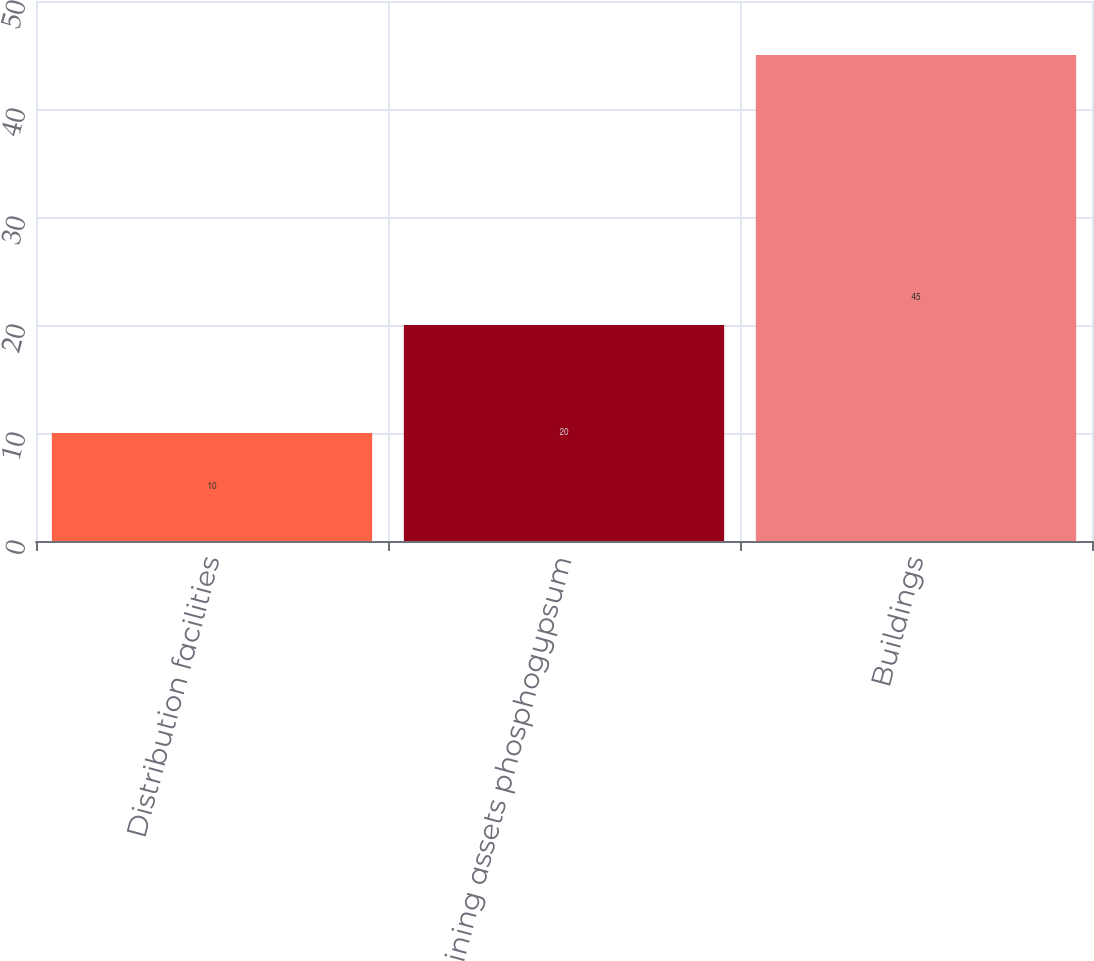Convert chart to OTSL. <chart><loc_0><loc_0><loc_500><loc_500><bar_chart><fcel>Distribution facilities<fcel>Mining assets phosphogypsum<fcel>Buildings<nl><fcel>10<fcel>20<fcel>45<nl></chart> 